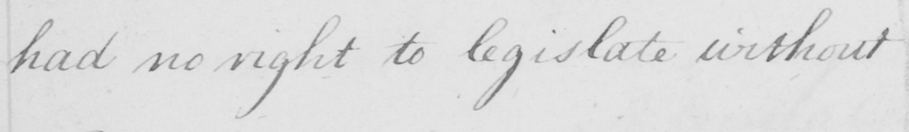Please transcribe the handwritten text in this image. had no right to legislate without 